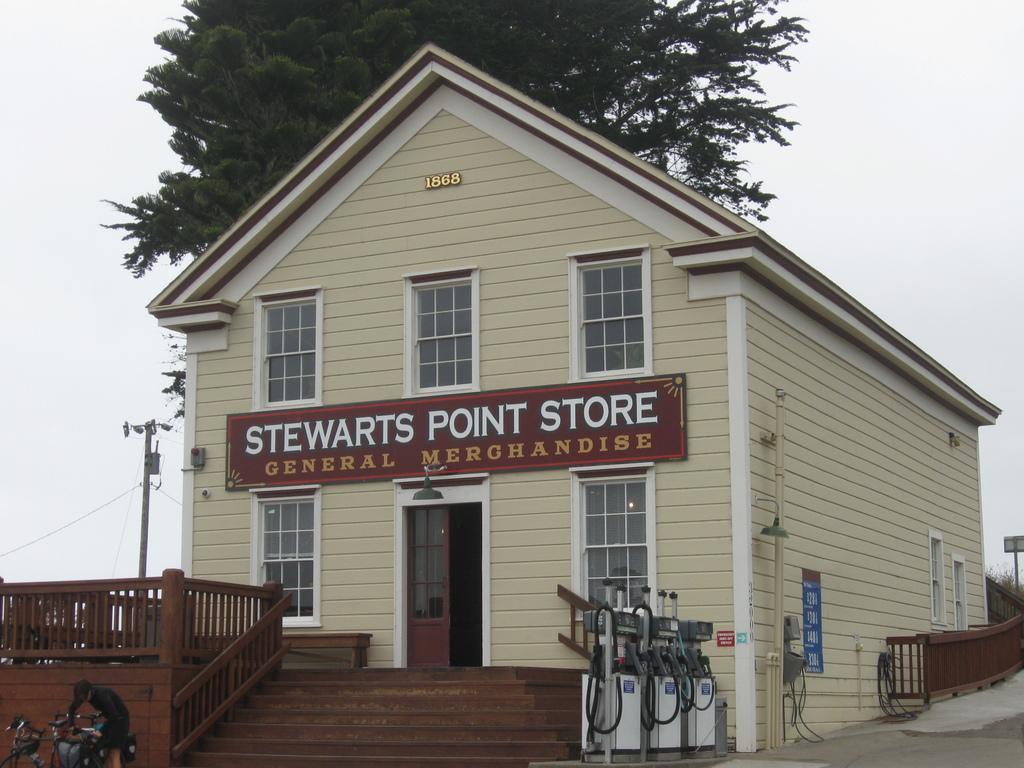Please provide a concise description of this image. In the foreground of the image we can see some devices with pipes placed on the ground. In the center of the image we can see a building with windows, door, staircase, railing and a sign board with some text. To the left side of the image we can see some bicycles on the ground, a person standing. In the background, we can see a pole with cables, tree and the sky. 